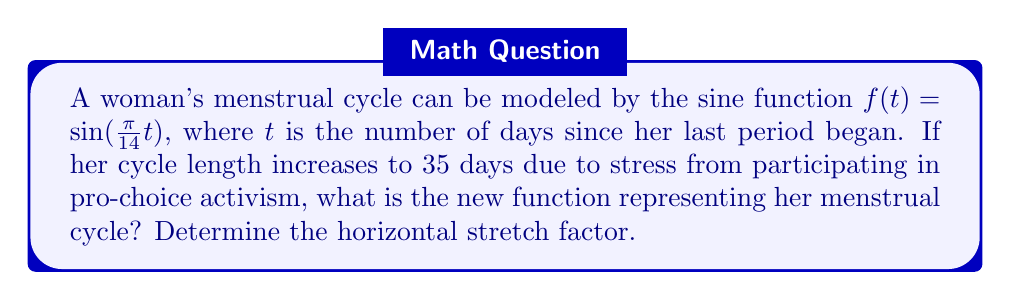Can you answer this question? To solve this problem, we need to follow these steps:

1) The original function $f(t) = \sin(\frac{\pi}{14}t)$ represents a cycle of 28 days, as one full cycle of a sine function occurs over $2\pi$ radians:

   $\frac{\pi}{14} \cdot 28 = 2\pi$

2) The new cycle length is 35 days. To stretch the function horizontally to represent this longer cycle, we need to multiply the input $t$ by a factor $k$ inside the sine function:

   $g(t) = \sin(k \cdot \frac{\pi}{14}t)$

3) To find $k$, we set up the equation:

   $k \cdot \frac{\pi}{14} \cdot 35 = 2\pi$

4) Solving for $k$:

   $k \cdot \frac{5\pi}{2} = 2\pi$
   $k = \frac{4}{5} = 0.8$

5) Therefore, the new function is:

   $g(t) = \sin(0.8 \cdot \frac{\pi}{14}t) = \sin(\frac{\pi}{17.5}t)$

6) The horizontal stretch factor is the reciprocal of $k$, which is $\frac{5}{4} = 1.25$.

This means the graph is stretched horizontally by a factor of 1.25, representing the longer 35-day cycle.
Answer: The new function is $g(t) = \sin(\frac{\pi}{17.5}t)$, and the horizontal stretch factor is 1.25. 